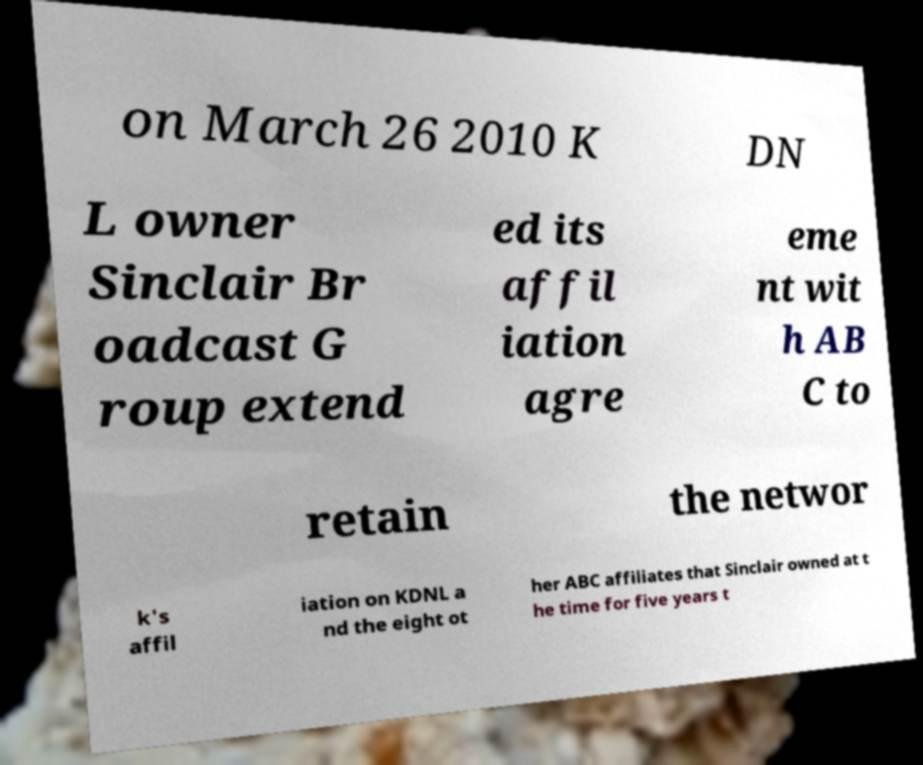I need the written content from this picture converted into text. Can you do that? on March 26 2010 K DN L owner Sinclair Br oadcast G roup extend ed its affil iation agre eme nt wit h AB C to retain the networ k's affil iation on KDNL a nd the eight ot her ABC affiliates that Sinclair owned at t he time for five years t 